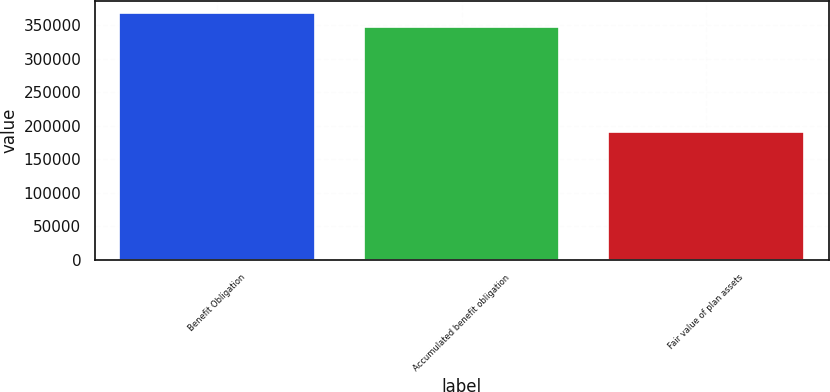Convert chart. <chart><loc_0><loc_0><loc_500><loc_500><bar_chart><fcel>Benefit Obligation<fcel>Accumulated benefit obligation<fcel>Fair value of plan assets<nl><fcel>367460<fcel>346684<fcel>189827<nl></chart> 